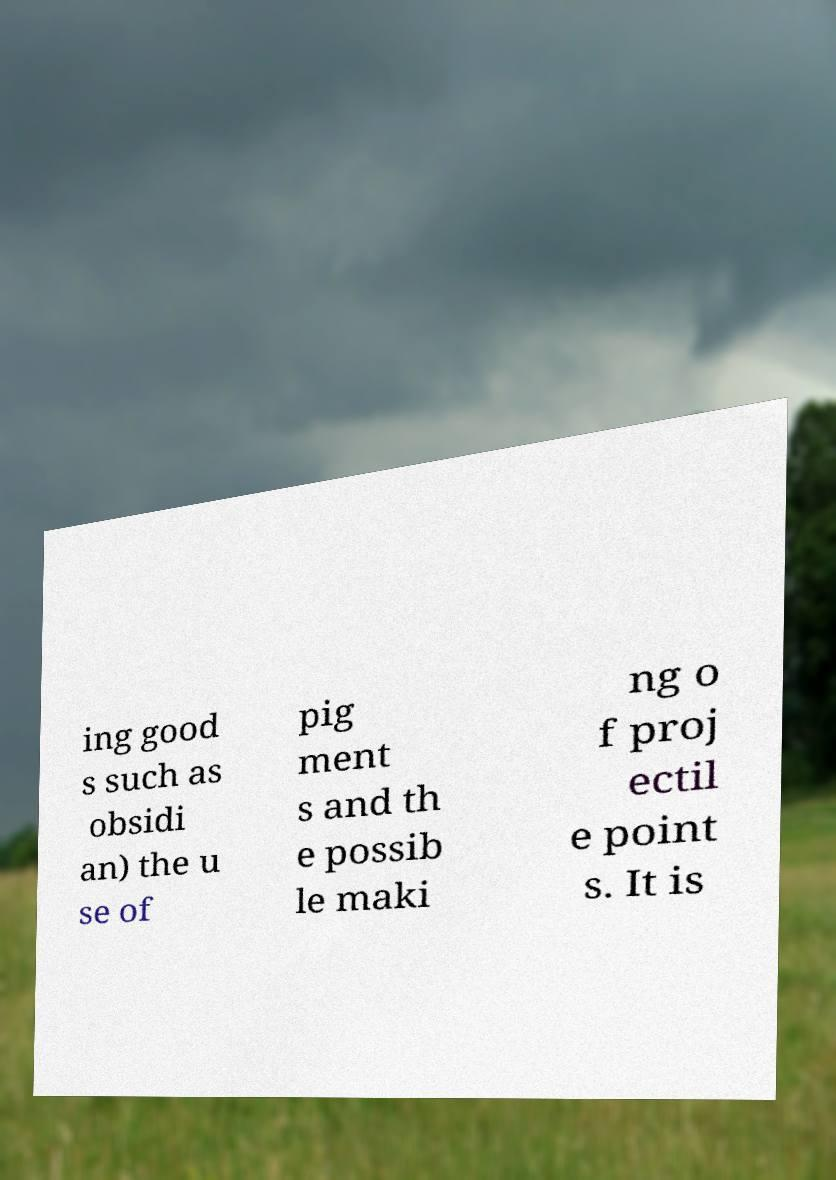There's text embedded in this image that I need extracted. Can you transcribe it verbatim? ing good s such as obsidi an) the u se of pig ment s and th e possib le maki ng o f proj ectil e point s. It is 